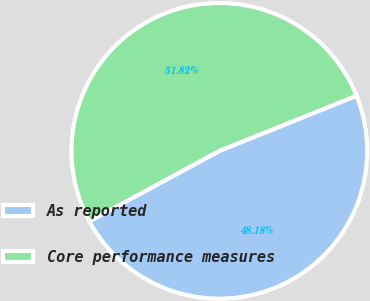<chart> <loc_0><loc_0><loc_500><loc_500><pie_chart><fcel>As reported<fcel>Core performance measures<nl><fcel>48.18%<fcel>51.82%<nl></chart> 